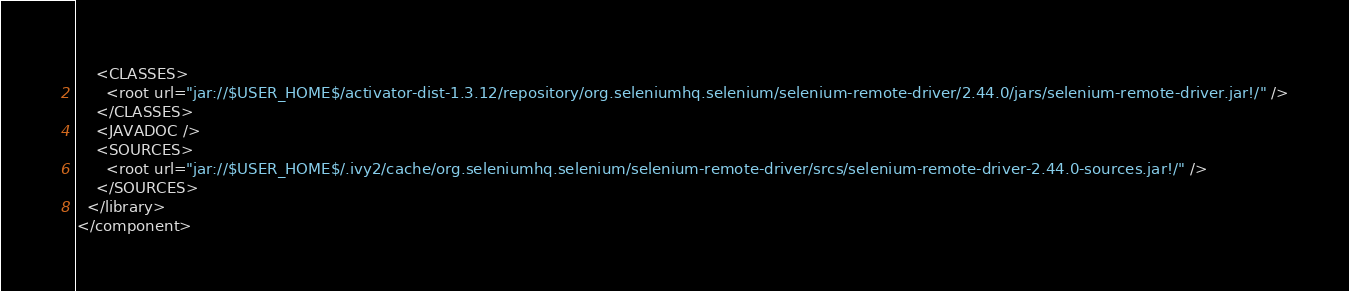<code> <loc_0><loc_0><loc_500><loc_500><_XML_>    <CLASSES>
      <root url="jar://$USER_HOME$/activator-dist-1.3.12/repository/org.seleniumhq.selenium/selenium-remote-driver/2.44.0/jars/selenium-remote-driver.jar!/" />
    </CLASSES>
    <JAVADOC />
    <SOURCES>
      <root url="jar://$USER_HOME$/.ivy2/cache/org.seleniumhq.selenium/selenium-remote-driver/srcs/selenium-remote-driver-2.44.0-sources.jar!/" />
    </SOURCES>
  </library>
</component></code> 